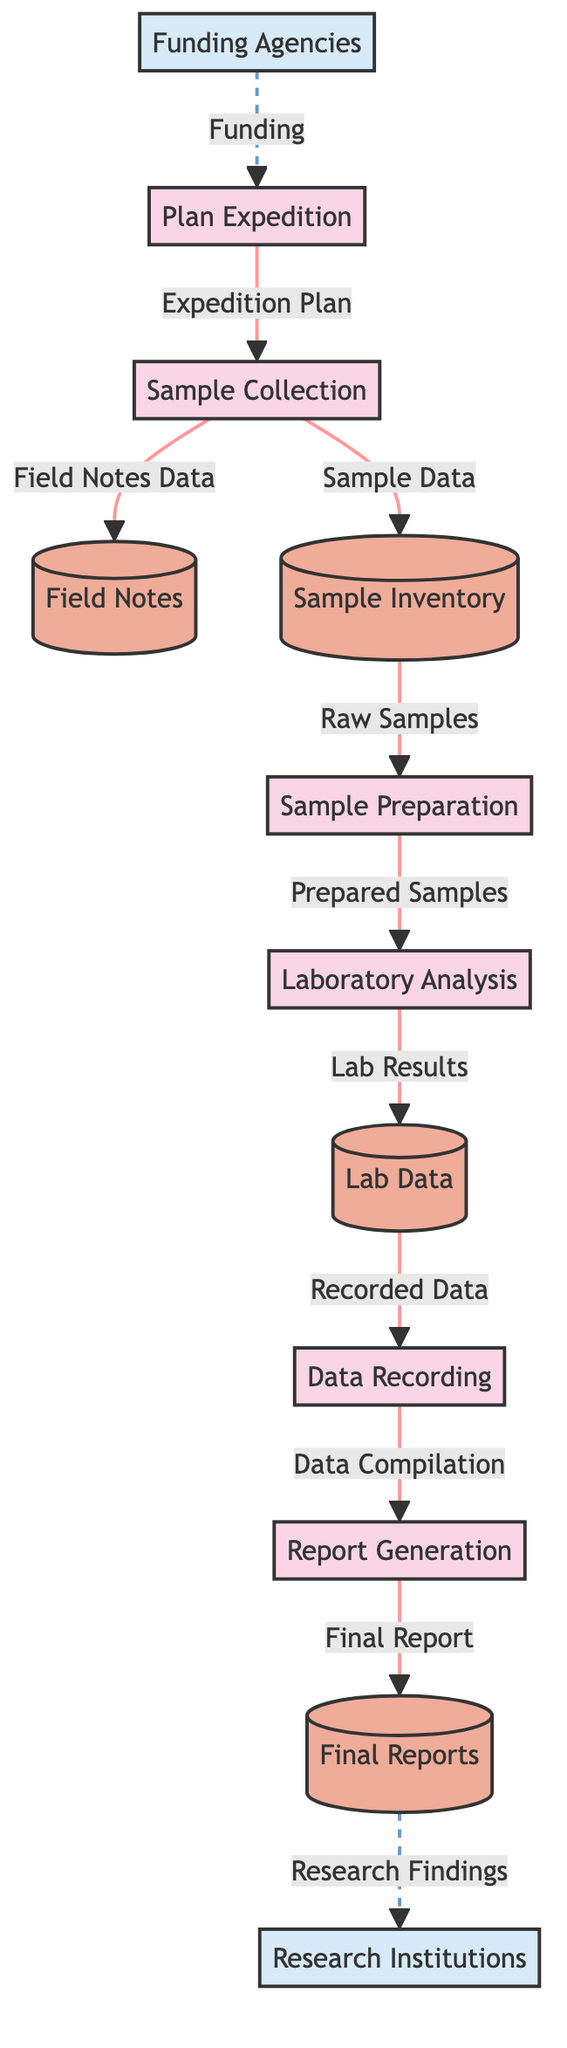What is the first process in the workflow? The first process in the diagram is labeled "Plan Expedition," which can be found at the start of the workflow.
Answer: Plan Expedition How many processes are there in total? By counting the boxes labeled as processes in the diagram, we find there are six distinct processes present.
Answer: Six What data store is used for initial observations taken during sample collection? The data store labeled "Field Notes" tracks observations made during the sample collection process, and it connects directly to the "Sample Collection" process.
Answer: Field Notes Which process receives the "Prepared Samples"? The "Sample Preparation" process provides the "Prepared Samples," which then flow into the "Laboratory Analysis" process for testing.
Answer: Laboratory Analysis What is the relationship between "Laboratory Analysis" and "Lab Data"? The "Laboratory Analysis" process generates results and measurements, which are then stored in the "Lab Data" datastore; this flow is clearly marked as "Lab Results."
Answer: Generates What data flows from "Data Recording" to "Report Generation"? The data flowing from "Data Recording" to "Report Generation" is labeled "Data Compilation," indicating that the recorded data needs to be compiled in this step.
Answer: Data Compilation Which external entity receives the "Final Reports"? The external entity labeled "Research Institutions" receives the "Final Reports," which is indicated by the directed dashed line in the diagram.
Answer: Research Institutions What is the purpose of the "Final Reports" data store? The "Final Reports" data store serves as a repository for all finalized reports containing the findings and data collected from the analysis of clay samples.
Answer: Comprehensive report 